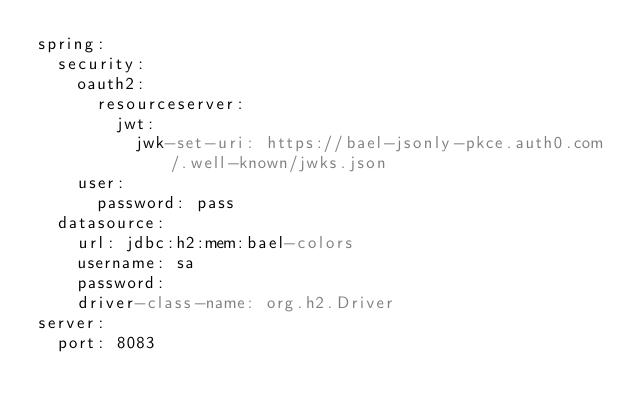Convert code to text. <code><loc_0><loc_0><loc_500><loc_500><_YAML_>spring:
  security:
    oauth2:
      resourceserver:
        jwt:
          jwk-set-uri: https://bael-jsonly-pkce.auth0.com/.well-known/jwks.json
    user:
      password: pass
  datasource:
    url: jdbc:h2:mem:bael-colors
    username: sa
    password: 
    driver-class-name: org.h2.Driver
server:
  port: 8083</code> 